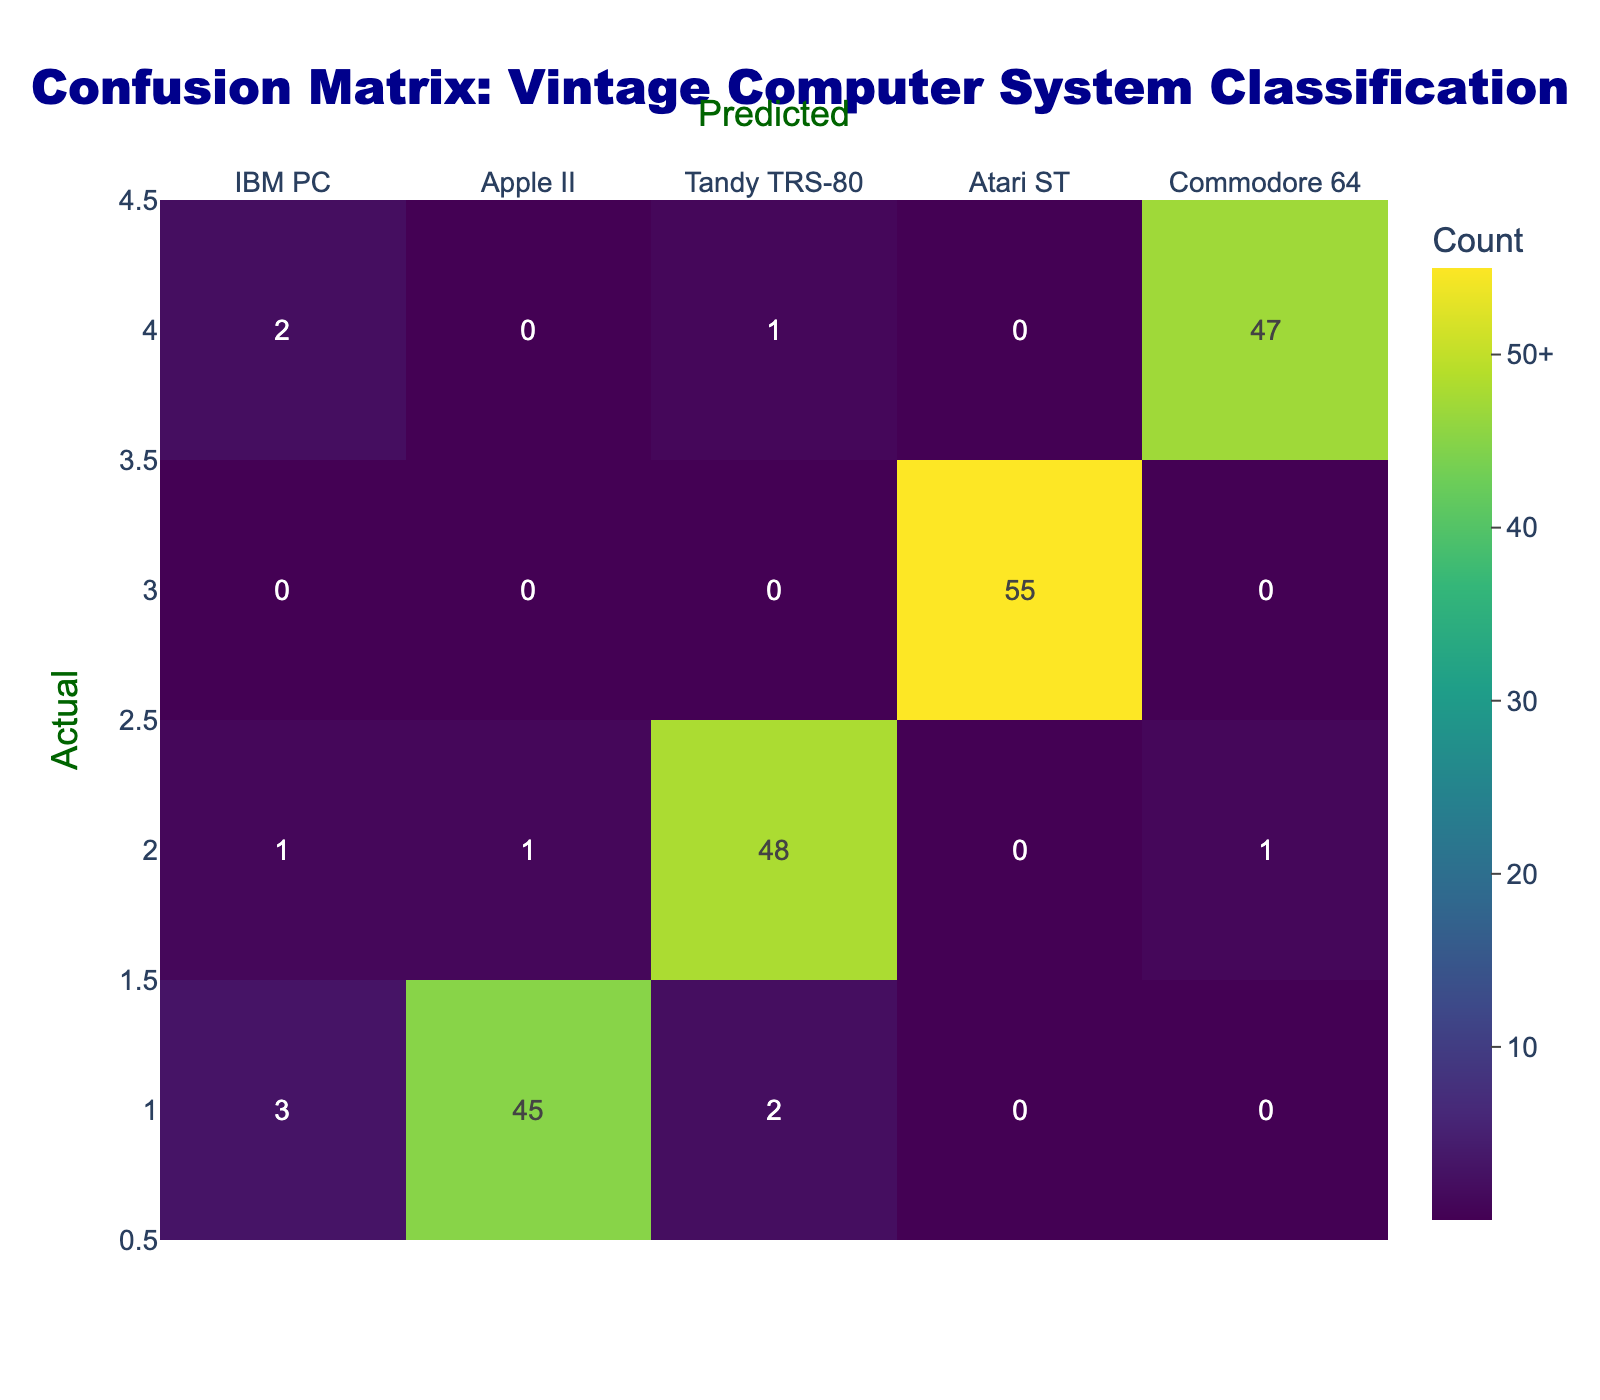What is the count of correct predictions for the IBM PC? The correct predictions for the IBM PC can be found in the intersection of the IBM PC row and the IBM PC column, which is 50.
Answer: 50 How many times was the Commodore 64 incorrectly classified as the Apple II? By looking at the Commodore 64 row and the Apple II column, we see there is a count of 0.
Answer: 0 What is the total number of misclassifications for the Apple II? To find the total misclassifications for the Apple II, we sum all the values in the Apple II row except for the correct prediction: 3 (IBM PC) + 2 (Tandy TRS-80) + 0 (Atari ST) + 0 (Commodore 64) = 5.
Answer: 5 Is the Atari ST more accurately classified than the Tandy TRS-80? We can compare their correct predictions: Atari ST has 55 correct predictions, while Tandy TRS-80 has 48. Therefore, Atari ST is classified more accurately.
Answer: Yes What is the average misclassification rate across all systems? First, calculate the total correct predictions. Summing the diagonal values gives 50 + 45 + 48 + 55 + 47 = 245. The total predictions for each system is 50 + 2 + 1 + 0 + 1 + 3 + 45 + 2 + 0 + 0 + 1 + 1 + 48 + 0 + 1 + 0 + 0 + 55 + 0 + 2 + 0 + 1 + 0 + 47 = 251. The misclassification total is 251 - 245 = 6. Average misclassification rate = 6 / 5 = 1.2.
Answer: 1.2 How many more times did the Tandy TRS-80 get misclassified as the Apple II compared to the IBM PC classification? The Tandy TRS-80 was misclassified as the Apple II once and the IBM PC was misclassified as the Tandy TRS-80 only once too, so there is no difference.
Answer: 0 